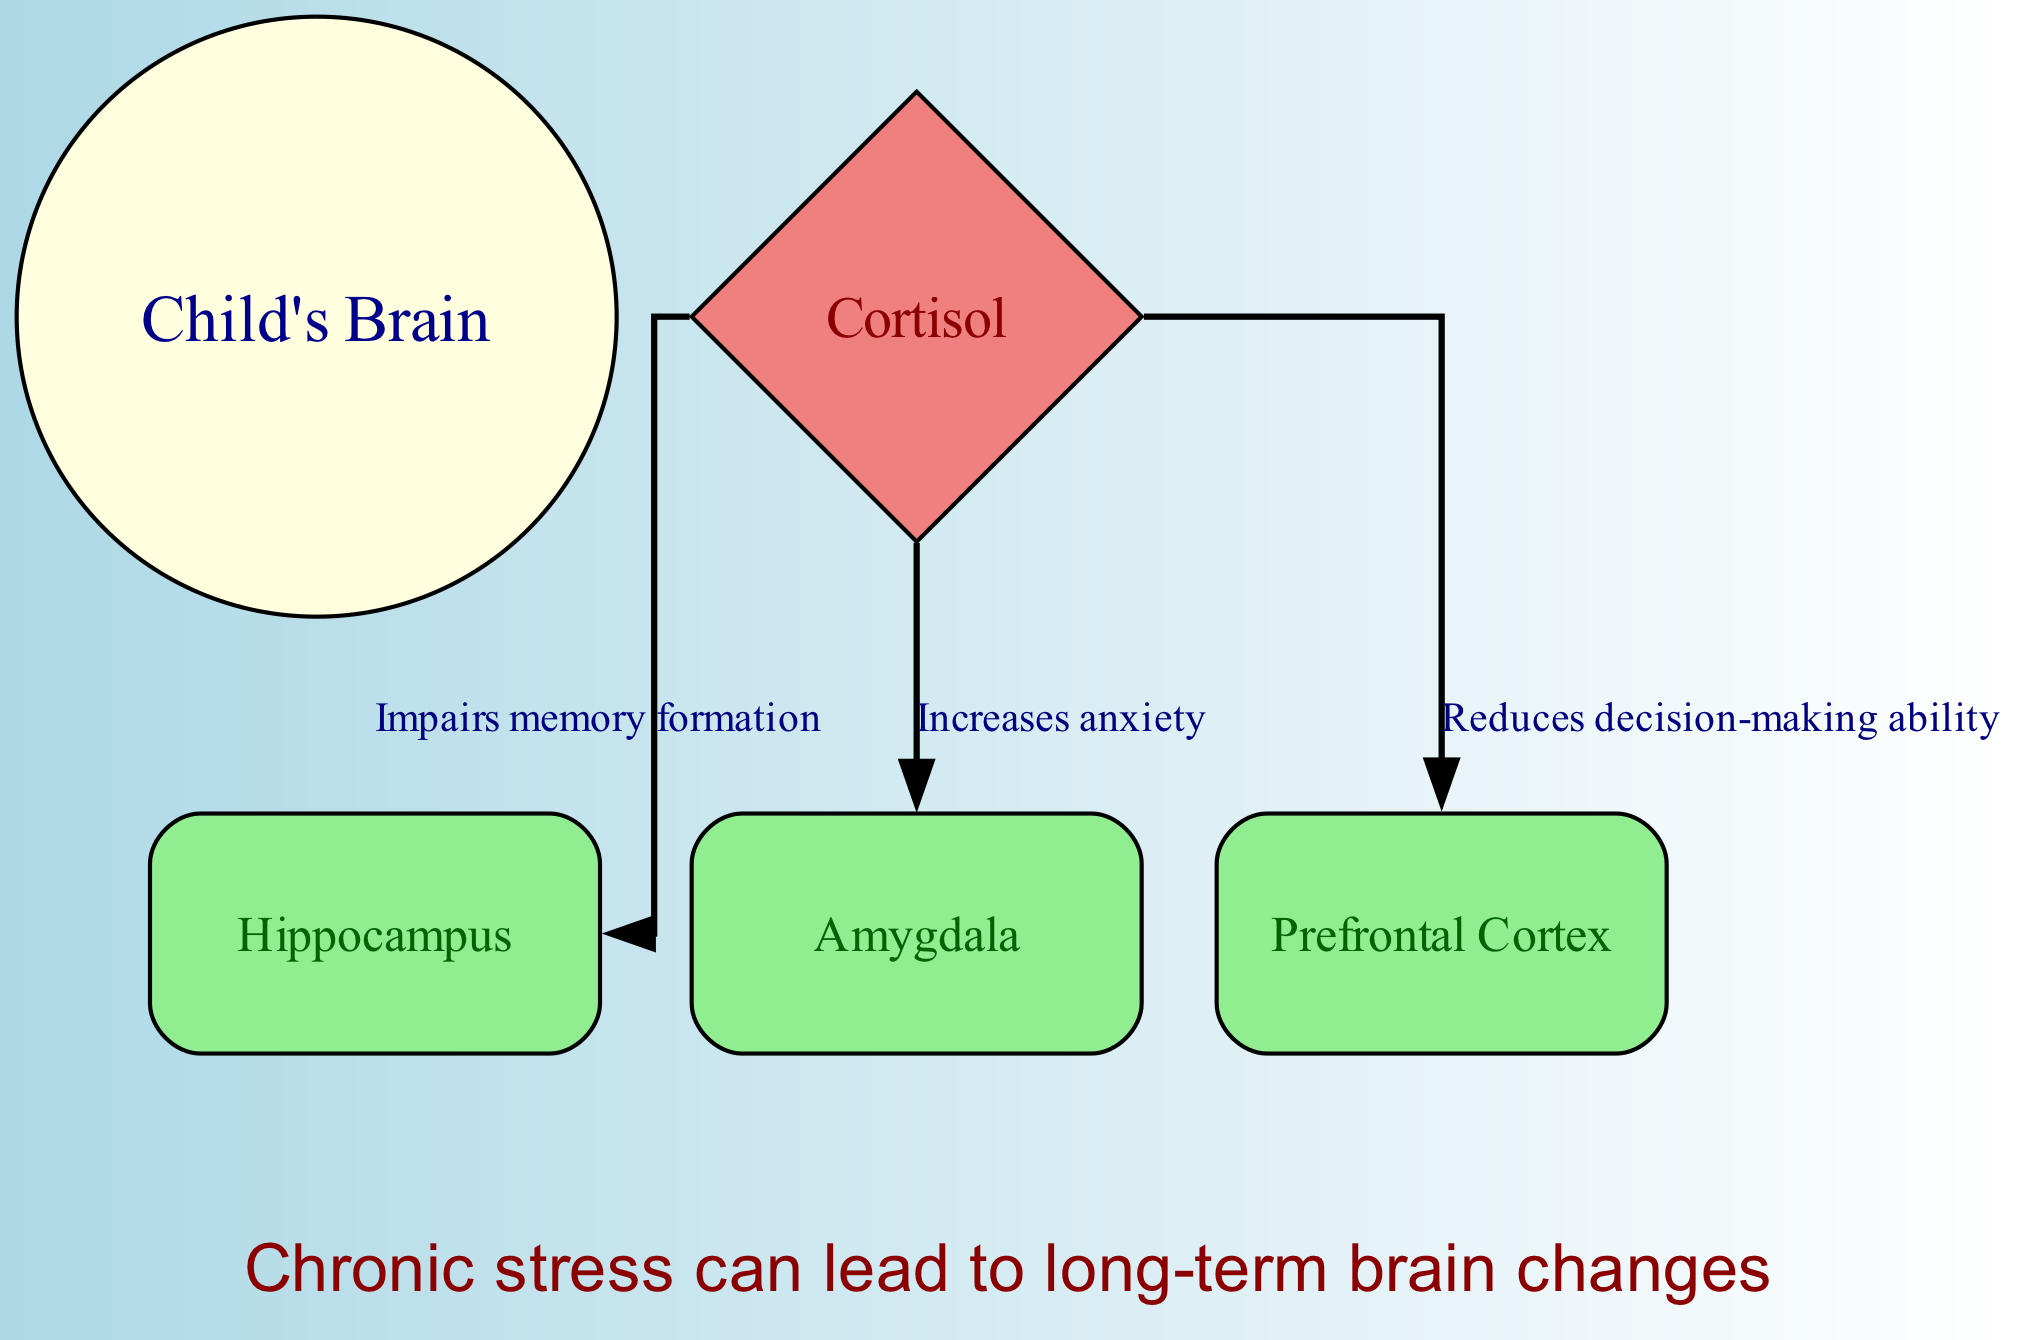What are the three brain areas affected by cortisol in the diagram? The diagram shows three brain areas impacted by cortisol: hippocampus, amygdala, and prefrontal cortex. These areas are explicitly labeled as nodes connected to the cortisol node by edges that illustrate their relationship.
Answer: hippocampus, amygdala, prefrontal cortex How does cortisol affect memory formation in a child's brain? The diagram indicates that cortisol impairs memory formation in the hippocampus, which is directly connected to the cortisol node. Therefore, the relationship shows cortisol's negative impact on memory.
Answer: Impairs memory formation What is the relationship between cortisol and anxiety according to the diagram? The diagram illustrates that cortisol increases anxiety, which is represented by a directed edge from the cortisol node to the amygdala node showing a clear relationship between them.
Answer: Increases anxiety What are the two annotations present in the diagram? The diagram contains two annotations: one stating "Prolonged custody disputes increase cortisol levels" and another stating "Chronic stress can lead to long-term brain changes." Both annotations are depicted at the top and bottom of the diagram, respectively.
Answer: Prolonged custody disputes increase cortisol levels, Chronic stress can lead to long-term brain changes Which brain region is associated with decision-making ability? The diagram shows that the prefrontal cortex is associated with decision-making ability. The relationship is depicted by an edge from the cortisol node indicating that cortisol reduces decision-making ability in this brain region.
Answer: Prefrontal Cortex How many edges are there connecting cortisol to brain areas? The diagram has three edges connecting cortisol to the brain areas: one to the hippocampus, one to the amygdala, and one to the prefrontal cortex. Each edge represents a distinct effect of cortisol on these areas.
Answer: 3 What can chronic stress lead to as indicated in the diagram? The diagram states in its annotation that chronic stress can lead to long-term brain changes. This phrase is highlighted at the bottom of the diagram, drawing attention to the consequences of prolonged stress.
Answer: Long-term brain changes 